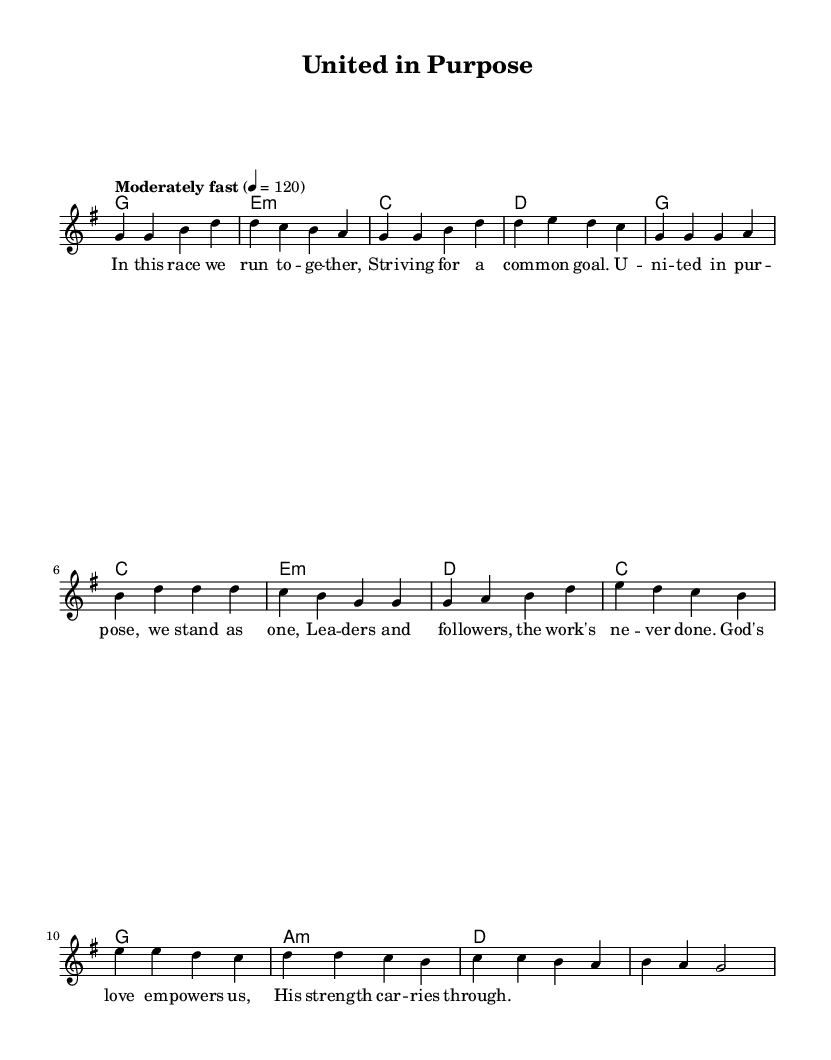What is the key signature of this music? The key signature is G major, which has one sharp (F#). This can be identified by looking at the key signature indicated at the beginning of the staff.
Answer: G major What is the time signature of the piece? The time signature is four-four, which can be observed by the notation present at the beginning of the score, indicating each measure contains four beats.
Answer: Four-four What is the tempo marking of this piece? The tempo marking states "Moderately fast" with a metronome marking of 120 beats per minute. This tempo information is usually placed at the start of the music to guide the performer.
Answer: Moderately fast What is the last note of the chorus? The last note of the chorus is a B, as seen at the end of the melodic line indicated for the chorus, which consistently follows the structural patterns shown earlier.
Answer: B What theme is emphasized in the lyrics? The lyrics emphasize teamwork and unity, which is a common theme in Christian rock anthems that promote working together in faith and purpose. This can be deduced from the words used in the lyrics.
Answer: Teamwork and unity What kind of chords are used in the bridge? The chords in the bridge include major and minor chords, specifically C major, G major, A minor, and D major. This can be verified by examining the harmonic line marked as `harmonies` corresponding to the bridge section of the song.
Answer: Major and minor chords 